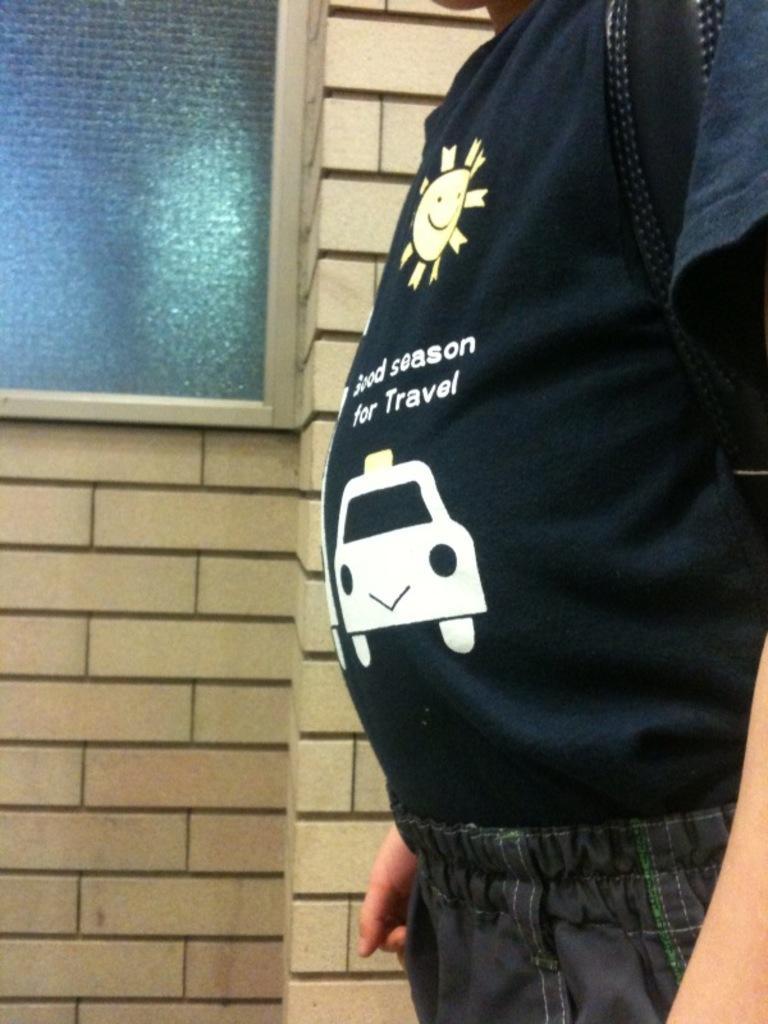How would you summarize this image in a sentence or two? In this image there is person standing on the floor by wearing a bag. At the back side there is a wall with the glass window. 